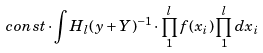Convert formula to latex. <formula><loc_0><loc_0><loc_500><loc_500>c o n s t \cdot \int H _ { l } ( y + Y ) ^ { - 1 } \cdot \prod _ { 1 } ^ { l } f ( x _ { i } ) \prod _ { 1 } ^ { l } d x _ { i }</formula> 